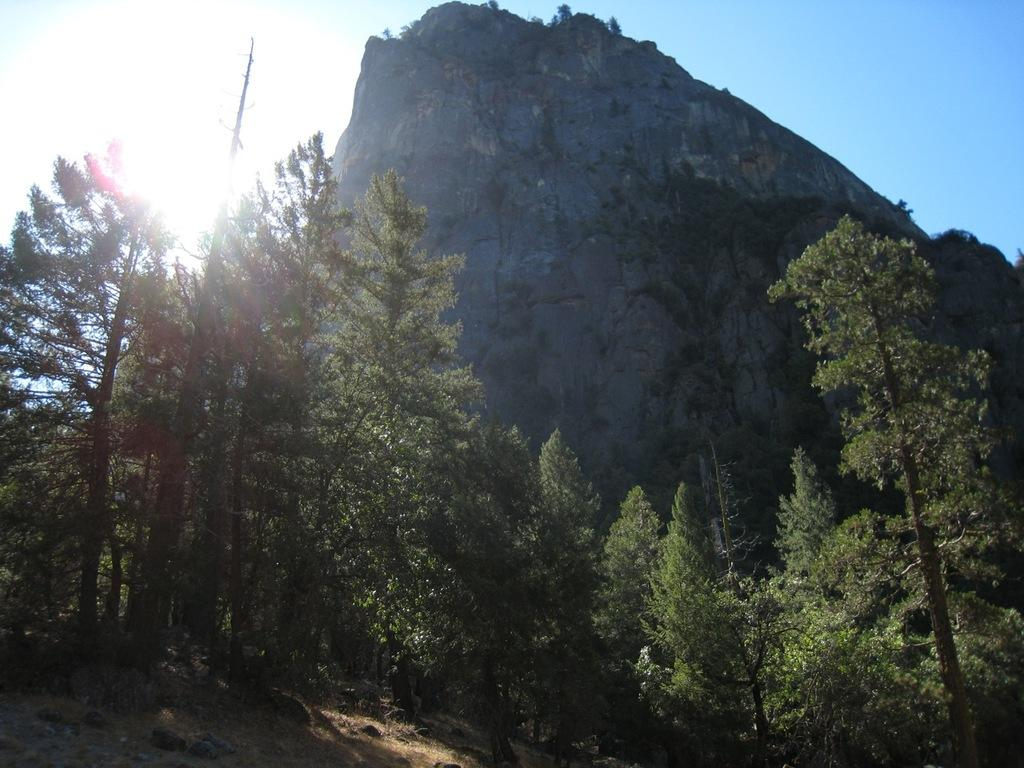What type of geographical feature is present in the image? There is a mountain in the image. What type of vegetation can be seen in the image? There are trees in the image. What is visible at the top of the image? The sky is visible at the top of the image. How many tomatoes are growing on the mountain in the image? There are no tomatoes present in the image; it features a mountain and trees. What part of the person's body can be seen interacting with the mountain in the image? There is no person or leg visible in the image; it only features a mountain and trees. 